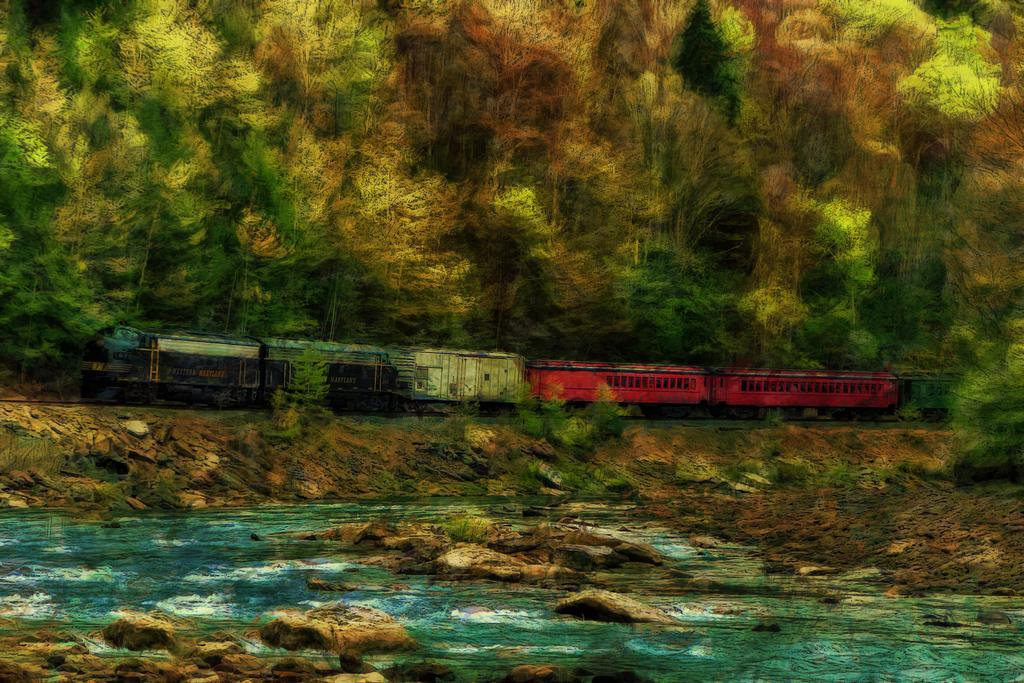What is depicted in the art in the image? There is an art of a train in the image. What else can be seen in the image besides the train art? There is water with rocks and trees in the image. What type of cheese is being served on the train in the image? There is no cheese or train service depicted in the image; it only features an art of a train and the surrounding environment. 